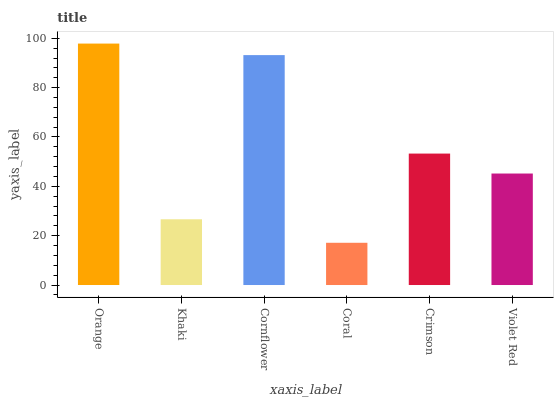Is Coral the minimum?
Answer yes or no. Yes. Is Orange the maximum?
Answer yes or no. Yes. Is Khaki the minimum?
Answer yes or no. No. Is Khaki the maximum?
Answer yes or no. No. Is Orange greater than Khaki?
Answer yes or no. Yes. Is Khaki less than Orange?
Answer yes or no. Yes. Is Khaki greater than Orange?
Answer yes or no. No. Is Orange less than Khaki?
Answer yes or no. No. Is Crimson the high median?
Answer yes or no. Yes. Is Violet Red the low median?
Answer yes or no. Yes. Is Cornflower the high median?
Answer yes or no. No. Is Crimson the low median?
Answer yes or no. No. 